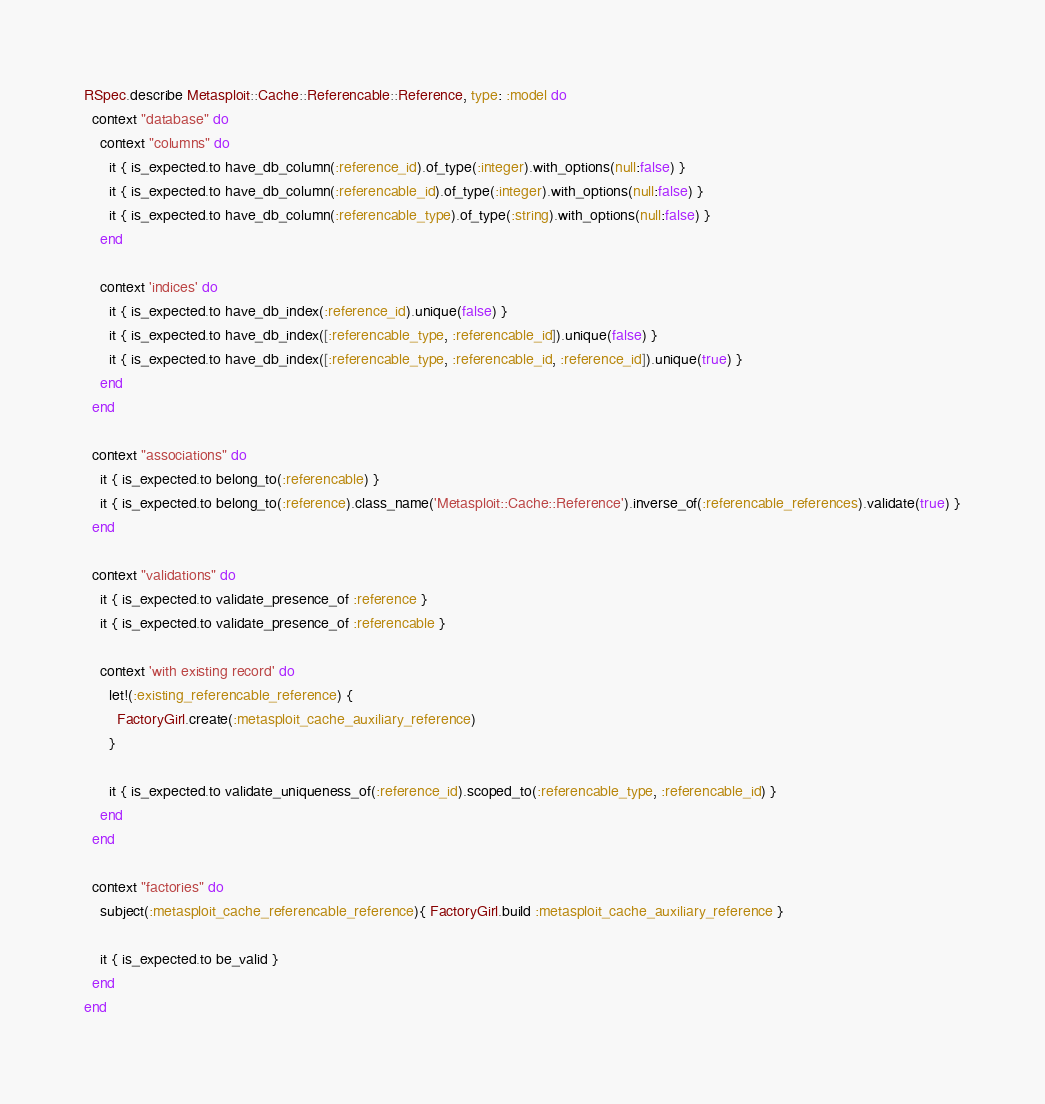Convert code to text. <code><loc_0><loc_0><loc_500><loc_500><_Ruby_>RSpec.describe Metasploit::Cache::Referencable::Reference, type: :model do
  context "database" do
    context "columns" do
      it { is_expected.to have_db_column(:reference_id).of_type(:integer).with_options(null:false) }
      it { is_expected.to have_db_column(:referencable_id).of_type(:integer).with_options(null:false) }
      it { is_expected.to have_db_column(:referencable_type).of_type(:string).with_options(null:false) }
    end

    context 'indices' do
      it { is_expected.to have_db_index(:reference_id).unique(false) }
      it { is_expected.to have_db_index([:referencable_type, :referencable_id]).unique(false) }
      it { is_expected.to have_db_index([:referencable_type, :referencable_id, :reference_id]).unique(true) }
    end
  end

  context "associations" do
    it { is_expected.to belong_to(:referencable) }
    it { is_expected.to belong_to(:reference).class_name('Metasploit::Cache::Reference').inverse_of(:referencable_references).validate(true) }
  end

  context "validations" do
    it { is_expected.to validate_presence_of :reference }
    it { is_expected.to validate_presence_of :referencable }

    context 'with existing record' do
      let!(:existing_referencable_reference) {
        FactoryGirl.create(:metasploit_cache_auxiliary_reference)
      }

      it { is_expected.to validate_uniqueness_of(:reference_id).scoped_to(:referencable_type, :referencable_id) }
    end
  end

  context "factories" do
    subject(:metasploit_cache_referencable_reference){ FactoryGirl.build :metasploit_cache_auxiliary_reference }

    it { is_expected.to be_valid }
  end
end</code> 